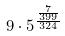<formula> <loc_0><loc_0><loc_500><loc_500>9 \cdot 5 ^ { \frac { \frac { 7 } { 3 9 9 } } { 3 2 4 } }</formula> 